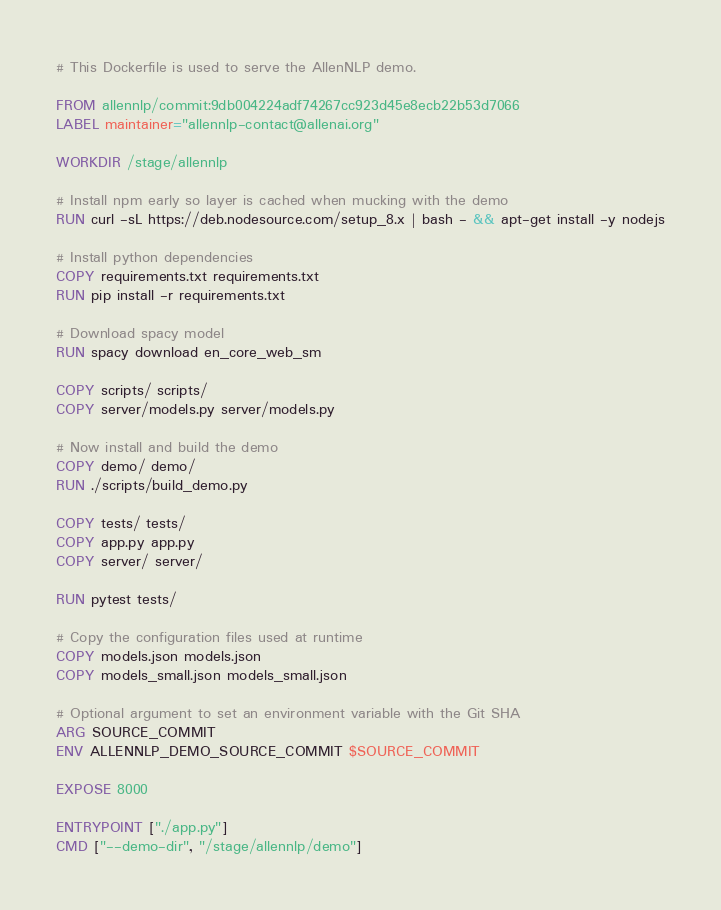Convert code to text. <code><loc_0><loc_0><loc_500><loc_500><_Dockerfile_># This Dockerfile is used to serve the AllenNLP demo.

FROM allennlp/commit:9db004224adf74267cc923d45e8ecb22b53d7066
LABEL maintainer="allennlp-contact@allenai.org"

WORKDIR /stage/allennlp

# Install npm early so layer is cached when mucking with the demo
RUN curl -sL https://deb.nodesource.com/setup_8.x | bash - && apt-get install -y nodejs

# Install python dependencies
COPY requirements.txt requirements.txt
RUN pip install -r requirements.txt

# Download spacy model
RUN spacy download en_core_web_sm

COPY scripts/ scripts/
COPY server/models.py server/models.py

# Now install and build the demo
COPY demo/ demo/
RUN ./scripts/build_demo.py

COPY tests/ tests/
COPY app.py app.py
COPY server/ server/

RUN pytest tests/

# Copy the configuration files used at runtime
COPY models.json models.json
COPY models_small.json models_small.json

# Optional argument to set an environment variable with the Git SHA
ARG SOURCE_COMMIT
ENV ALLENNLP_DEMO_SOURCE_COMMIT $SOURCE_COMMIT

EXPOSE 8000

ENTRYPOINT ["./app.py"]
CMD ["--demo-dir", "/stage/allennlp/demo"]
</code> 